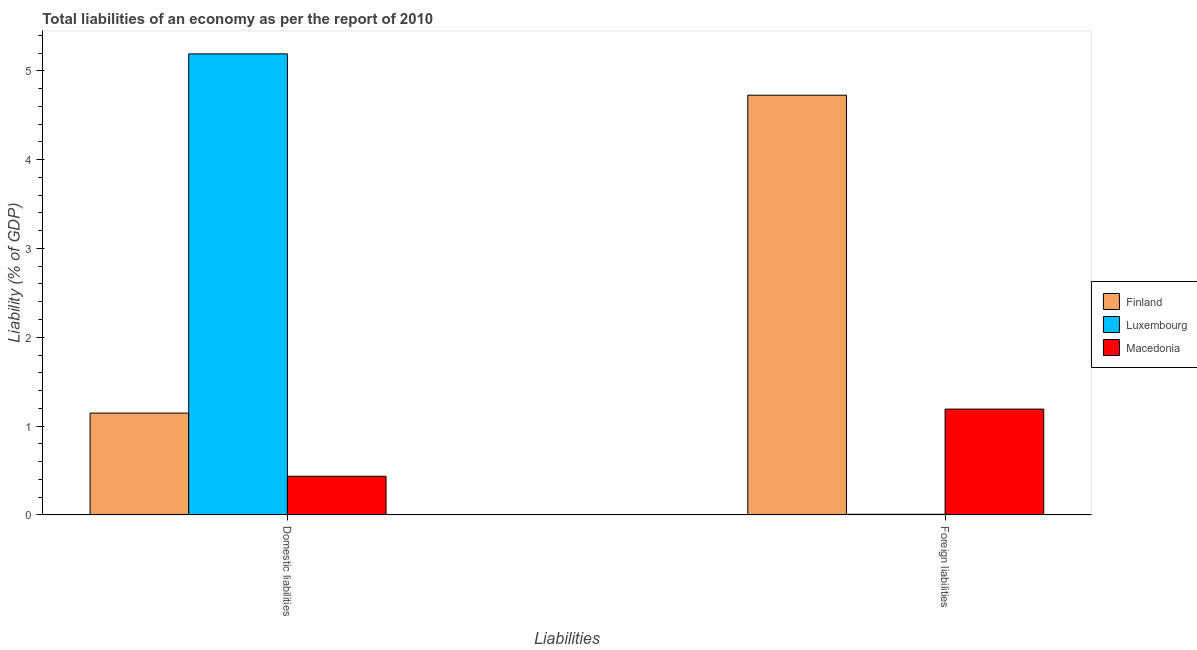How many groups of bars are there?
Your response must be concise. 2. Are the number of bars on each tick of the X-axis equal?
Offer a very short reply. Yes. How many bars are there on the 2nd tick from the right?
Provide a short and direct response. 3. What is the label of the 1st group of bars from the left?
Provide a short and direct response. Domestic liabilities. What is the incurrence of domestic liabilities in Luxembourg?
Your answer should be very brief. 5.19. Across all countries, what is the maximum incurrence of foreign liabilities?
Provide a short and direct response. 4.73. Across all countries, what is the minimum incurrence of foreign liabilities?
Offer a terse response. 0.01. In which country was the incurrence of domestic liabilities maximum?
Provide a short and direct response. Luxembourg. In which country was the incurrence of domestic liabilities minimum?
Ensure brevity in your answer.  Macedonia. What is the total incurrence of foreign liabilities in the graph?
Ensure brevity in your answer.  5.92. What is the difference between the incurrence of domestic liabilities in Luxembourg and that in Macedonia?
Offer a very short reply. 4.75. What is the difference between the incurrence of foreign liabilities in Finland and the incurrence of domestic liabilities in Macedonia?
Provide a short and direct response. 4.29. What is the average incurrence of foreign liabilities per country?
Provide a succinct answer. 1.97. What is the difference between the incurrence of domestic liabilities and incurrence of foreign liabilities in Macedonia?
Make the answer very short. -0.76. In how many countries, is the incurrence of domestic liabilities greater than 2.2 %?
Provide a succinct answer. 1. What is the ratio of the incurrence of domestic liabilities in Luxembourg to that in Macedonia?
Keep it short and to the point. 11.92. What does the 2nd bar from the left in Domestic liabilities represents?
Your answer should be compact. Luxembourg. What is the difference between two consecutive major ticks on the Y-axis?
Offer a terse response. 1. Where does the legend appear in the graph?
Offer a very short reply. Center right. What is the title of the graph?
Provide a succinct answer. Total liabilities of an economy as per the report of 2010. What is the label or title of the X-axis?
Offer a very short reply. Liabilities. What is the label or title of the Y-axis?
Offer a terse response. Liability (% of GDP). What is the Liability (% of GDP) of Finland in Domestic liabilities?
Give a very brief answer. 1.15. What is the Liability (% of GDP) in Luxembourg in Domestic liabilities?
Provide a short and direct response. 5.19. What is the Liability (% of GDP) of Macedonia in Domestic liabilities?
Make the answer very short. 0.44. What is the Liability (% of GDP) of Finland in Foreign liabilities?
Keep it short and to the point. 4.73. What is the Liability (% of GDP) of Luxembourg in Foreign liabilities?
Provide a succinct answer. 0.01. What is the Liability (% of GDP) in Macedonia in Foreign liabilities?
Offer a very short reply. 1.19. Across all Liabilities, what is the maximum Liability (% of GDP) in Finland?
Make the answer very short. 4.73. Across all Liabilities, what is the maximum Liability (% of GDP) in Luxembourg?
Give a very brief answer. 5.19. Across all Liabilities, what is the maximum Liability (% of GDP) of Macedonia?
Keep it short and to the point. 1.19. Across all Liabilities, what is the minimum Liability (% of GDP) in Finland?
Ensure brevity in your answer.  1.15. Across all Liabilities, what is the minimum Liability (% of GDP) in Luxembourg?
Ensure brevity in your answer.  0.01. Across all Liabilities, what is the minimum Liability (% of GDP) of Macedonia?
Ensure brevity in your answer.  0.44. What is the total Liability (% of GDP) in Finland in the graph?
Ensure brevity in your answer.  5.87. What is the total Liability (% of GDP) of Luxembourg in the graph?
Offer a very short reply. 5.2. What is the total Liability (% of GDP) in Macedonia in the graph?
Offer a very short reply. 1.63. What is the difference between the Liability (% of GDP) of Finland in Domestic liabilities and that in Foreign liabilities?
Your response must be concise. -3.58. What is the difference between the Liability (% of GDP) of Luxembourg in Domestic liabilities and that in Foreign liabilities?
Your response must be concise. 5.18. What is the difference between the Liability (% of GDP) in Macedonia in Domestic liabilities and that in Foreign liabilities?
Give a very brief answer. -0.76. What is the difference between the Liability (% of GDP) in Finland in Domestic liabilities and the Liability (% of GDP) in Luxembourg in Foreign liabilities?
Offer a very short reply. 1.14. What is the difference between the Liability (% of GDP) in Finland in Domestic liabilities and the Liability (% of GDP) in Macedonia in Foreign liabilities?
Make the answer very short. -0.04. What is the difference between the Liability (% of GDP) of Luxembourg in Domestic liabilities and the Liability (% of GDP) of Macedonia in Foreign liabilities?
Ensure brevity in your answer.  4. What is the average Liability (% of GDP) in Finland per Liabilities?
Offer a very short reply. 2.94. What is the average Liability (% of GDP) in Luxembourg per Liabilities?
Make the answer very short. 2.6. What is the average Liability (% of GDP) in Macedonia per Liabilities?
Provide a short and direct response. 0.81. What is the difference between the Liability (% of GDP) of Finland and Liability (% of GDP) of Luxembourg in Domestic liabilities?
Your response must be concise. -4.04. What is the difference between the Liability (% of GDP) of Finland and Liability (% of GDP) of Macedonia in Domestic liabilities?
Make the answer very short. 0.71. What is the difference between the Liability (% of GDP) of Luxembourg and Liability (% of GDP) of Macedonia in Domestic liabilities?
Offer a terse response. 4.75. What is the difference between the Liability (% of GDP) of Finland and Liability (% of GDP) of Luxembourg in Foreign liabilities?
Your response must be concise. 4.72. What is the difference between the Liability (% of GDP) of Finland and Liability (% of GDP) of Macedonia in Foreign liabilities?
Give a very brief answer. 3.53. What is the difference between the Liability (% of GDP) of Luxembourg and Liability (% of GDP) of Macedonia in Foreign liabilities?
Your answer should be very brief. -1.18. What is the ratio of the Liability (% of GDP) of Finland in Domestic liabilities to that in Foreign liabilities?
Make the answer very short. 0.24. What is the ratio of the Liability (% of GDP) in Luxembourg in Domestic liabilities to that in Foreign liabilities?
Keep it short and to the point. 683.84. What is the ratio of the Liability (% of GDP) of Macedonia in Domestic liabilities to that in Foreign liabilities?
Offer a terse response. 0.37. What is the difference between the highest and the second highest Liability (% of GDP) in Finland?
Your response must be concise. 3.58. What is the difference between the highest and the second highest Liability (% of GDP) in Luxembourg?
Make the answer very short. 5.18. What is the difference between the highest and the second highest Liability (% of GDP) in Macedonia?
Your answer should be very brief. 0.76. What is the difference between the highest and the lowest Liability (% of GDP) in Finland?
Provide a succinct answer. 3.58. What is the difference between the highest and the lowest Liability (% of GDP) of Luxembourg?
Offer a terse response. 5.18. What is the difference between the highest and the lowest Liability (% of GDP) in Macedonia?
Offer a terse response. 0.76. 